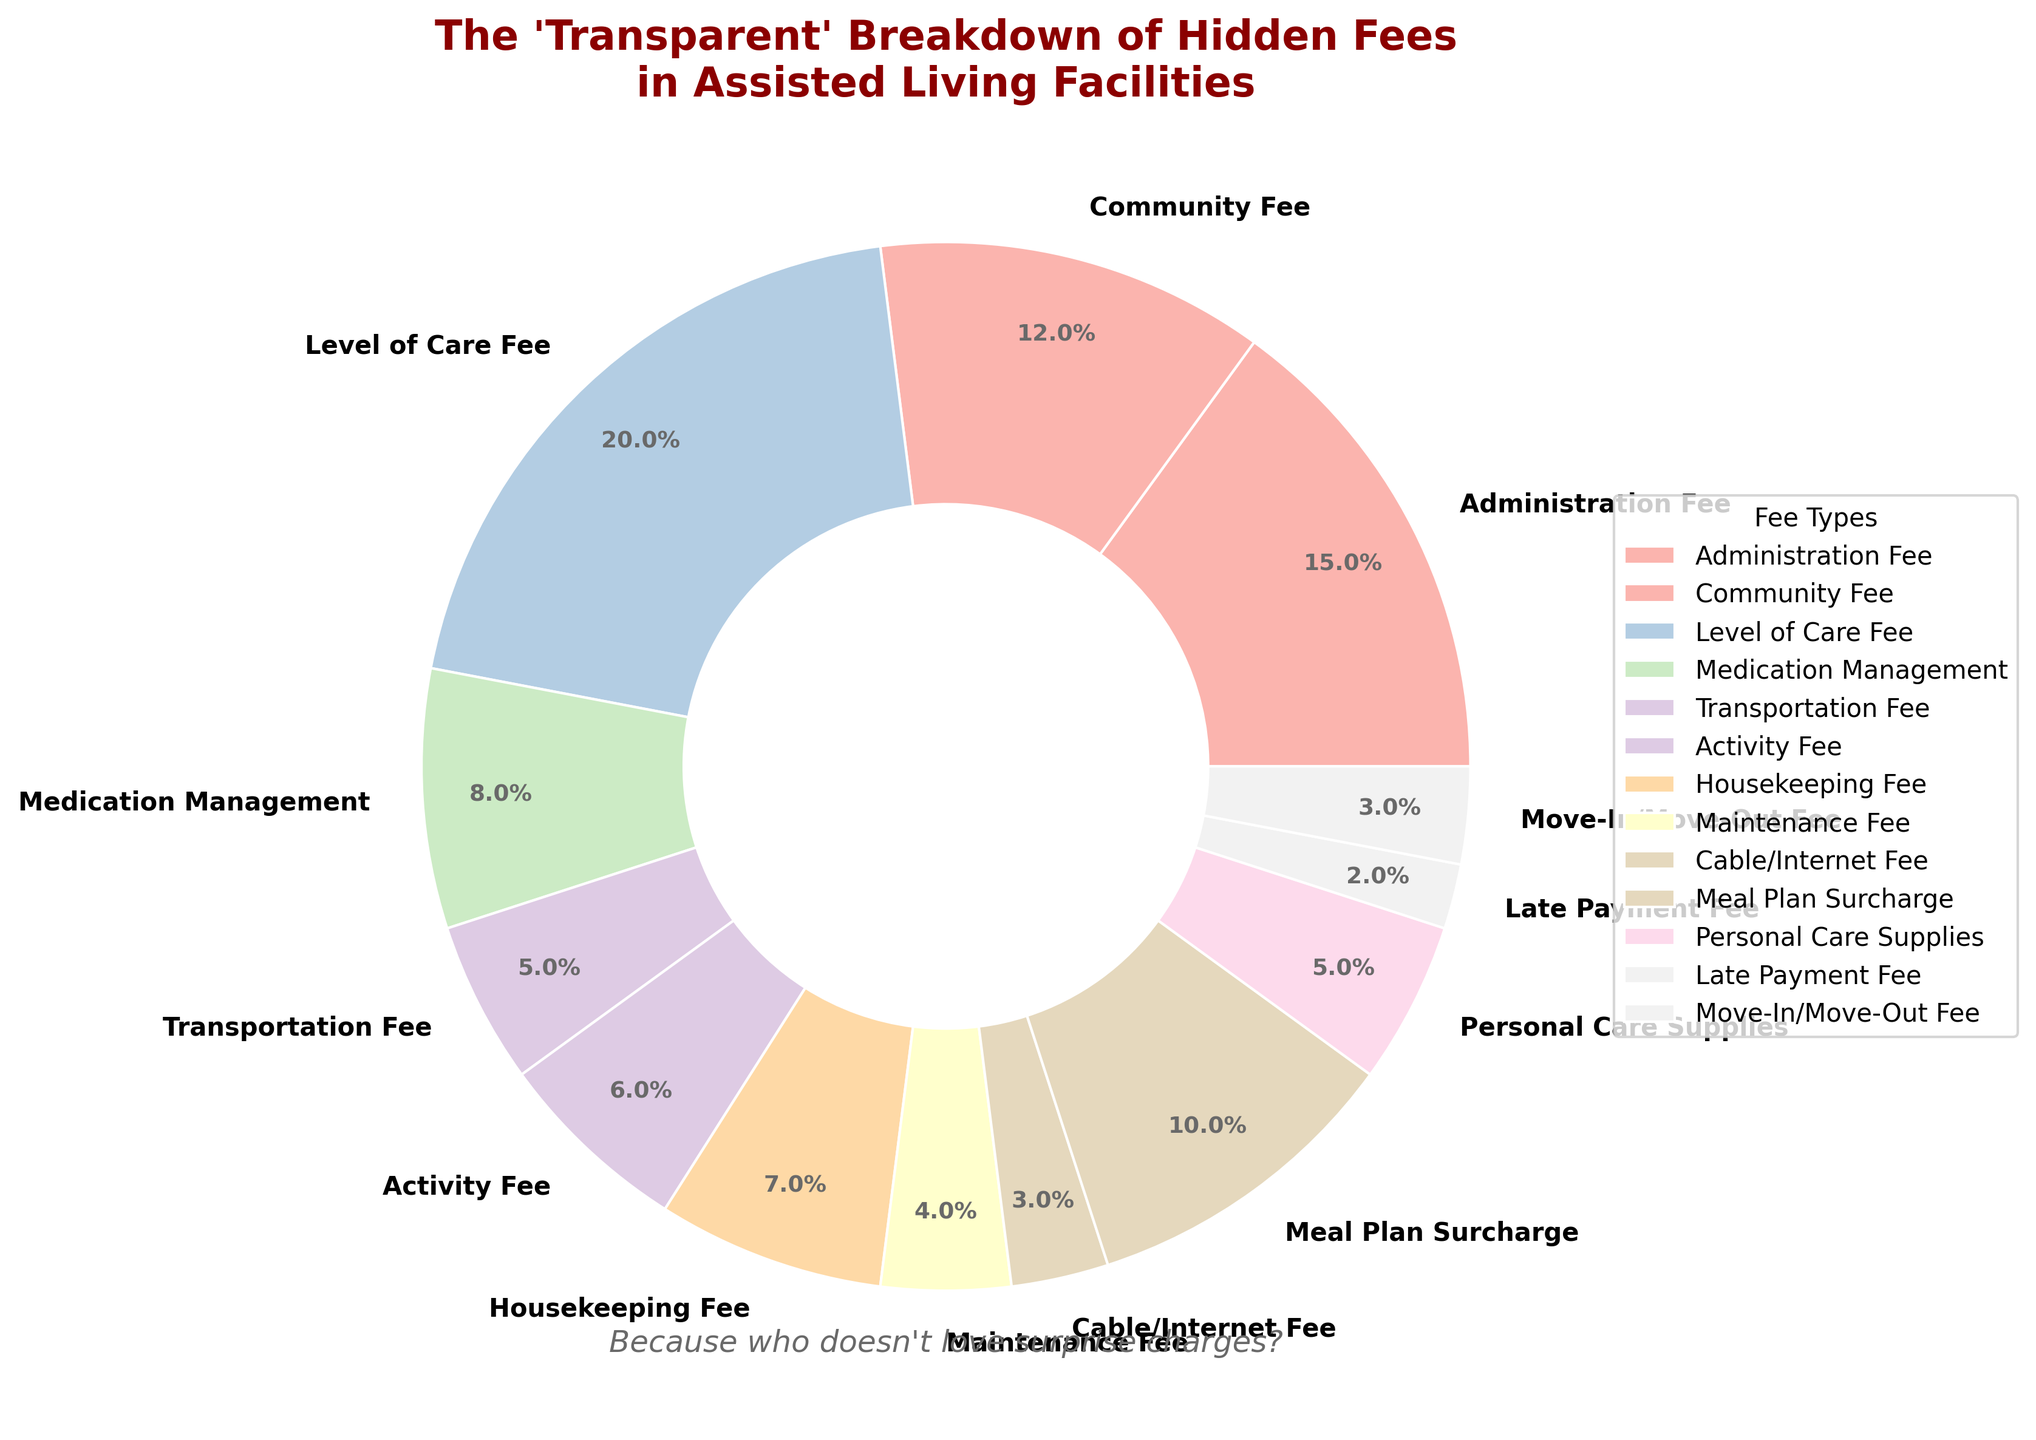What hidden fee has the highest percentage in the pie chart? Identify the segment with the largest percentage value. The "Level of Care Fee" has the highest value, indicated by being the largest slice.
Answer: Level of Care Fee What's the combined percentage of "Administration Fee" and "Community Fee"? Add the percentages of the "Administration Fee" (15%) and the "Community Fee" (12%). The sum is 15% + 12% = 27%.
Answer: 27% Which type of hidden fee is larger, "Housekeeping Fee" or "Transportation Fee"? Compare the percentages of the "Housekeeping Fee" (7%) and the "Transportation Fee" (5%). 7% is greater than 5%.
Answer: Housekeeping Fee What's the total percentage for fees related to personal services, including "Medication Management," "Personal Care Supplies," and the "Level of Care Fee"? Add the percentages: "Medication Management" (8%), "Personal Care Supplies" (5%), and "Level of Care Fee" (20%). 8% + 5% + 20% = 33%.
Answer: 33% How much greater is the "Meal Plan Surcharge" than the "Move-In/Move-Out Fee"? Subtract the percentage of the "Move-In/Move-Out Fee" (3%) from the "Meal Plan Surcharge" (10%). 10% - 3% = 7%.
Answer: 7% Which fee is indicated by the lightest color segment? Look for the segment filled with the lightest shade in the pastel color palette, which corresponds to "Cable/Internet Fee."
Answer: Cable/Internet Fee Which fees are less than 5%? Identify the segments with percentages less than 5%. These are "Maintenance Fee" (4%), "Cable/Internet Fee" (3%), "Late Payment Fee" (2%), and "Move-In/Move-Out Fee" (3%).
Answer: Maintenance Fee, Cable/Internet Fee, Late Payment Fee, Move-In/Move-Out Fee Between the "Activity Fee" and "Housekeeping Fee," which one has a higher minimum percentage threshold for fee allocation? Compare their percentages: "Activity Fee" is 6% and "Housekeeping Fee" is 7%. 7% is higher than 6%.
Answer: Housekeeping Fee What is the ratio of "Maintenance Fee" to "Transportation Fee"? Divide the percentage of the "Maintenance Fee" (4%) by the "Transportation Fee" (5%). 4/5 = 0.8.
Answer: 0.8 